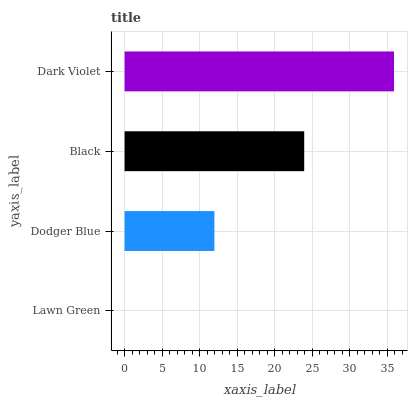Is Lawn Green the minimum?
Answer yes or no. Yes. Is Dark Violet the maximum?
Answer yes or no. Yes. Is Dodger Blue the minimum?
Answer yes or no. No. Is Dodger Blue the maximum?
Answer yes or no. No. Is Dodger Blue greater than Lawn Green?
Answer yes or no. Yes. Is Lawn Green less than Dodger Blue?
Answer yes or no. Yes. Is Lawn Green greater than Dodger Blue?
Answer yes or no. No. Is Dodger Blue less than Lawn Green?
Answer yes or no. No. Is Black the high median?
Answer yes or no. Yes. Is Dodger Blue the low median?
Answer yes or no. Yes. Is Dodger Blue the high median?
Answer yes or no. No. Is Dark Violet the low median?
Answer yes or no. No. 